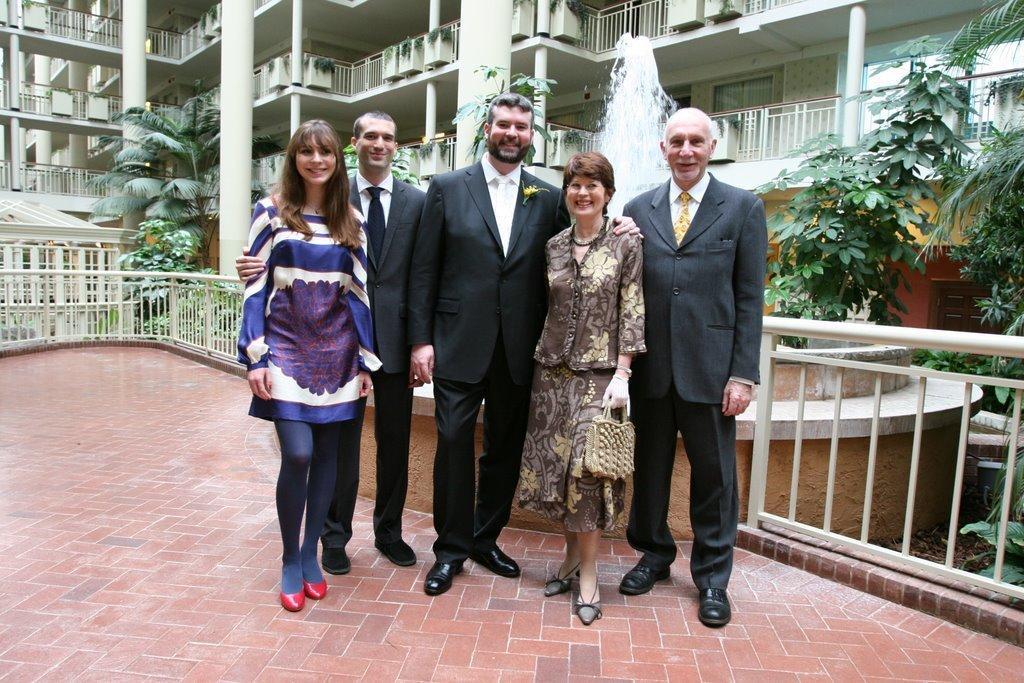In one or two sentences, can you explain what this image depicts? In this image in the center there are persons standing and smiling. In the background there is a building and there are pillars, trees and there is a fence in the center. 